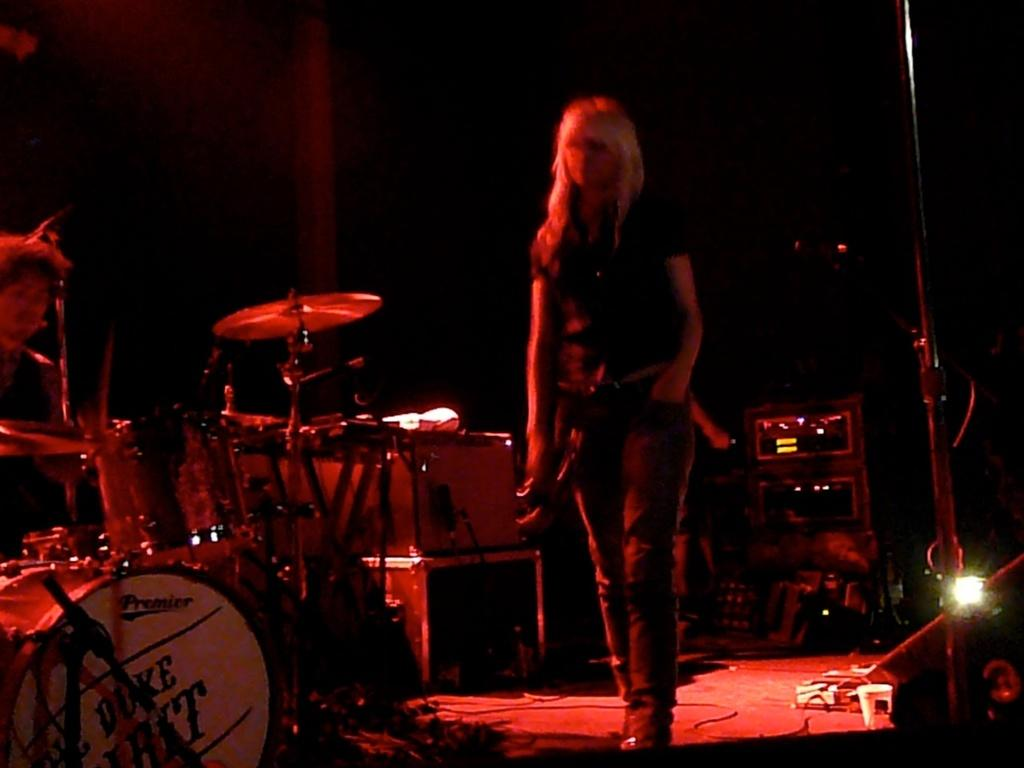What is the woman doing in the image? The woman is walking on a stage. What else can be seen on the stage besides the woman? There are musical instruments and speakers on the stage. What is used to illuminate the stage? There is a light on the stage. How would you describe the background of the image? The background of the image is dark in color. How many toes can be seen on the bird in the image? There is no bird present in the image, so it is not possible to determine the number of toes on a bird. 